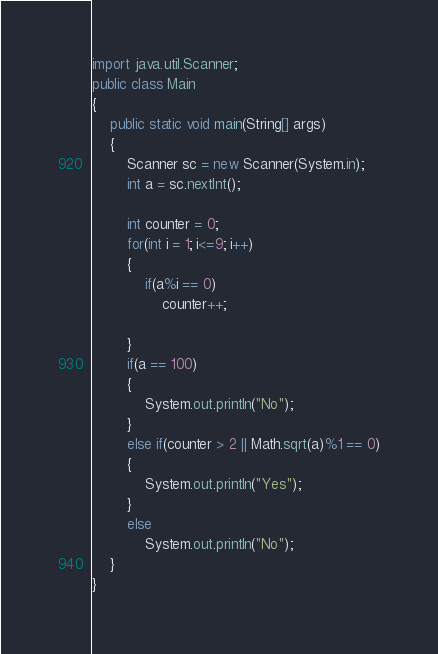<code> <loc_0><loc_0><loc_500><loc_500><_Java_>import java.util.Scanner;
public class Main
{
	public static void main(String[] args)
	{
		Scanner sc = new Scanner(System.in);
		int a = sc.nextInt();

		int counter = 0;
		for(int i = 1; i<=9; i++)
		{
			if(a%i == 0)
				counter++;

		}
		if(a == 100)
		{
			System.out.println("No");
		}
		else if(counter > 2 || Math.sqrt(a)%1 == 0)
		{
			System.out.println("Yes");
		}
		else
			System.out.println("No");
	}
}
</code> 